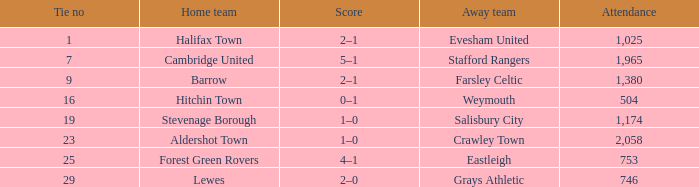How many attended tie number 19? 1174.0. 